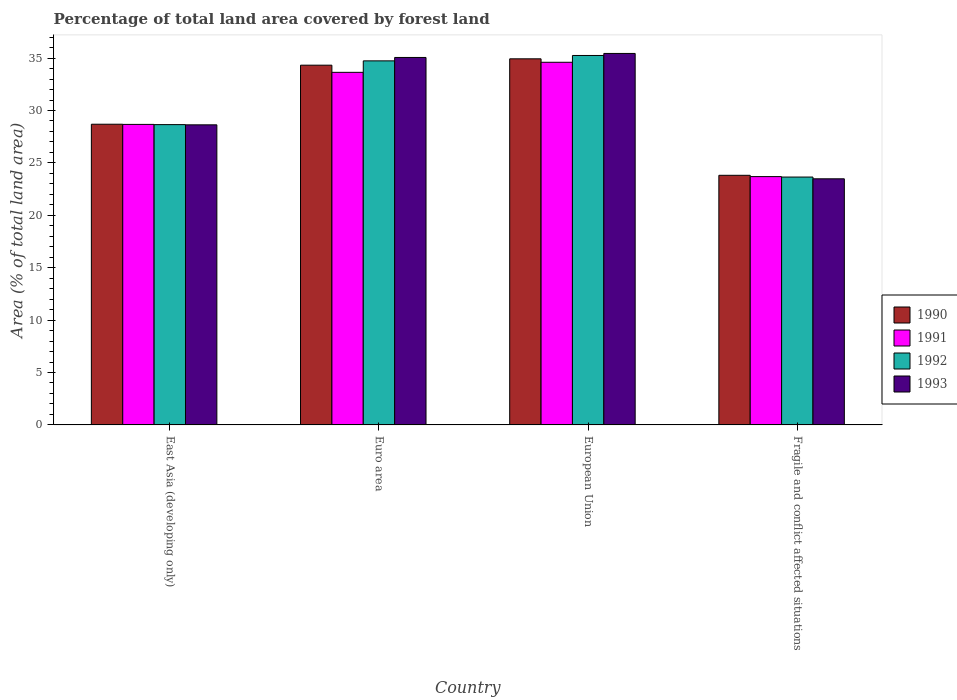How many different coloured bars are there?
Provide a short and direct response. 4. How many groups of bars are there?
Ensure brevity in your answer.  4. Are the number of bars per tick equal to the number of legend labels?
Provide a short and direct response. Yes. How many bars are there on the 4th tick from the left?
Keep it short and to the point. 4. In how many cases, is the number of bars for a given country not equal to the number of legend labels?
Ensure brevity in your answer.  0. What is the percentage of forest land in 1990 in European Union?
Ensure brevity in your answer.  34.93. Across all countries, what is the maximum percentage of forest land in 1991?
Provide a succinct answer. 34.6. Across all countries, what is the minimum percentage of forest land in 1993?
Provide a short and direct response. 23.48. In which country was the percentage of forest land in 1991 minimum?
Your response must be concise. Fragile and conflict affected situations. What is the total percentage of forest land in 1992 in the graph?
Give a very brief answer. 122.29. What is the difference between the percentage of forest land in 1990 in East Asia (developing only) and that in European Union?
Your answer should be compact. -6.24. What is the difference between the percentage of forest land in 1992 in Euro area and the percentage of forest land in 1993 in Fragile and conflict affected situations?
Your answer should be very brief. 11.25. What is the average percentage of forest land in 1993 per country?
Provide a succinct answer. 30.66. What is the difference between the percentage of forest land of/in 1993 and percentage of forest land of/in 1990 in European Union?
Your response must be concise. 0.51. In how many countries, is the percentage of forest land in 1992 greater than 2 %?
Provide a succinct answer. 4. What is the ratio of the percentage of forest land in 1993 in East Asia (developing only) to that in Fragile and conflict affected situations?
Give a very brief answer. 1.22. Is the percentage of forest land in 1992 in East Asia (developing only) less than that in Fragile and conflict affected situations?
Ensure brevity in your answer.  No. Is the difference between the percentage of forest land in 1993 in Euro area and European Union greater than the difference between the percentage of forest land in 1990 in Euro area and European Union?
Offer a very short reply. Yes. What is the difference between the highest and the second highest percentage of forest land in 1990?
Give a very brief answer. 0.61. What is the difference between the highest and the lowest percentage of forest land in 1992?
Keep it short and to the point. 11.6. Is the sum of the percentage of forest land in 1990 in East Asia (developing only) and Euro area greater than the maximum percentage of forest land in 1992 across all countries?
Your answer should be compact. Yes. Is it the case that in every country, the sum of the percentage of forest land in 1990 and percentage of forest land in 1992 is greater than the sum of percentage of forest land in 1991 and percentage of forest land in 1993?
Make the answer very short. No. What does the 2nd bar from the left in European Union represents?
Ensure brevity in your answer.  1991. Is it the case that in every country, the sum of the percentage of forest land in 1992 and percentage of forest land in 1993 is greater than the percentage of forest land in 1990?
Your answer should be very brief. Yes. Are all the bars in the graph horizontal?
Make the answer very short. No. How many countries are there in the graph?
Keep it short and to the point. 4. Are the values on the major ticks of Y-axis written in scientific E-notation?
Keep it short and to the point. No. Does the graph contain any zero values?
Provide a short and direct response. No. Where does the legend appear in the graph?
Offer a very short reply. Center right. How many legend labels are there?
Provide a short and direct response. 4. What is the title of the graph?
Your answer should be compact. Percentage of total land area covered by forest land. Does "1966" appear as one of the legend labels in the graph?
Your answer should be compact. No. What is the label or title of the X-axis?
Your answer should be very brief. Country. What is the label or title of the Y-axis?
Your response must be concise. Area (% of total land area). What is the Area (% of total land area) of 1990 in East Asia (developing only)?
Your answer should be very brief. 28.69. What is the Area (% of total land area) of 1991 in East Asia (developing only)?
Give a very brief answer. 28.68. What is the Area (% of total land area) of 1992 in East Asia (developing only)?
Your answer should be compact. 28.65. What is the Area (% of total land area) in 1993 in East Asia (developing only)?
Ensure brevity in your answer.  28.63. What is the Area (% of total land area) in 1990 in Euro area?
Make the answer very short. 34.33. What is the Area (% of total land area) of 1991 in Euro area?
Provide a short and direct response. 33.64. What is the Area (% of total land area) of 1992 in Euro area?
Provide a succinct answer. 34.74. What is the Area (% of total land area) of 1993 in Euro area?
Provide a succinct answer. 35.06. What is the Area (% of total land area) in 1990 in European Union?
Keep it short and to the point. 34.93. What is the Area (% of total land area) in 1991 in European Union?
Offer a very short reply. 34.6. What is the Area (% of total land area) in 1992 in European Union?
Ensure brevity in your answer.  35.25. What is the Area (% of total land area) of 1993 in European Union?
Keep it short and to the point. 35.45. What is the Area (% of total land area) in 1990 in Fragile and conflict affected situations?
Give a very brief answer. 23.82. What is the Area (% of total land area) of 1991 in Fragile and conflict affected situations?
Provide a short and direct response. 23.69. What is the Area (% of total land area) of 1992 in Fragile and conflict affected situations?
Offer a terse response. 23.65. What is the Area (% of total land area) in 1993 in Fragile and conflict affected situations?
Offer a terse response. 23.48. Across all countries, what is the maximum Area (% of total land area) of 1990?
Give a very brief answer. 34.93. Across all countries, what is the maximum Area (% of total land area) of 1991?
Ensure brevity in your answer.  34.6. Across all countries, what is the maximum Area (% of total land area) in 1992?
Give a very brief answer. 35.25. Across all countries, what is the maximum Area (% of total land area) in 1993?
Ensure brevity in your answer.  35.45. Across all countries, what is the minimum Area (% of total land area) of 1990?
Provide a succinct answer. 23.82. Across all countries, what is the minimum Area (% of total land area) in 1991?
Make the answer very short. 23.69. Across all countries, what is the minimum Area (% of total land area) in 1992?
Provide a short and direct response. 23.65. Across all countries, what is the minimum Area (% of total land area) in 1993?
Keep it short and to the point. 23.48. What is the total Area (% of total land area) of 1990 in the graph?
Make the answer very short. 121.77. What is the total Area (% of total land area) in 1991 in the graph?
Provide a short and direct response. 120.62. What is the total Area (% of total land area) in 1992 in the graph?
Offer a very short reply. 122.29. What is the total Area (% of total land area) of 1993 in the graph?
Ensure brevity in your answer.  122.63. What is the difference between the Area (% of total land area) of 1990 in East Asia (developing only) and that in Euro area?
Keep it short and to the point. -5.63. What is the difference between the Area (% of total land area) of 1991 in East Asia (developing only) and that in Euro area?
Provide a short and direct response. -4.97. What is the difference between the Area (% of total land area) in 1992 in East Asia (developing only) and that in Euro area?
Make the answer very short. -6.08. What is the difference between the Area (% of total land area) in 1993 in East Asia (developing only) and that in Euro area?
Keep it short and to the point. -6.43. What is the difference between the Area (% of total land area) in 1990 in East Asia (developing only) and that in European Union?
Make the answer very short. -6.24. What is the difference between the Area (% of total land area) in 1991 in East Asia (developing only) and that in European Union?
Make the answer very short. -5.93. What is the difference between the Area (% of total land area) of 1992 in East Asia (developing only) and that in European Union?
Your answer should be very brief. -6.6. What is the difference between the Area (% of total land area) in 1993 in East Asia (developing only) and that in European Union?
Provide a short and direct response. -6.81. What is the difference between the Area (% of total land area) of 1990 in East Asia (developing only) and that in Fragile and conflict affected situations?
Ensure brevity in your answer.  4.87. What is the difference between the Area (% of total land area) of 1991 in East Asia (developing only) and that in Fragile and conflict affected situations?
Provide a short and direct response. 4.98. What is the difference between the Area (% of total land area) of 1992 in East Asia (developing only) and that in Fragile and conflict affected situations?
Ensure brevity in your answer.  5. What is the difference between the Area (% of total land area) of 1993 in East Asia (developing only) and that in Fragile and conflict affected situations?
Your answer should be compact. 5.15. What is the difference between the Area (% of total land area) of 1990 in Euro area and that in European Union?
Your response must be concise. -0.61. What is the difference between the Area (% of total land area) in 1991 in Euro area and that in European Union?
Keep it short and to the point. -0.96. What is the difference between the Area (% of total land area) of 1992 in Euro area and that in European Union?
Provide a succinct answer. -0.51. What is the difference between the Area (% of total land area) of 1993 in Euro area and that in European Union?
Provide a succinct answer. -0.38. What is the difference between the Area (% of total land area) in 1990 in Euro area and that in Fragile and conflict affected situations?
Offer a terse response. 10.51. What is the difference between the Area (% of total land area) of 1991 in Euro area and that in Fragile and conflict affected situations?
Offer a very short reply. 9.95. What is the difference between the Area (% of total land area) in 1992 in Euro area and that in Fragile and conflict affected situations?
Offer a very short reply. 11.09. What is the difference between the Area (% of total land area) of 1993 in Euro area and that in Fragile and conflict affected situations?
Make the answer very short. 11.58. What is the difference between the Area (% of total land area) of 1990 in European Union and that in Fragile and conflict affected situations?
Your answer should be compact. 11.12. What is the difference between the Area (% of total land area) of 1991 in European Union and that in Fragile and conflict affected situations?
Your answer should be compact. 10.91. What is the difference between the Area (% of total land area) of 1992 in European Union and that in Fragile and conflict affected situations?
Your response must be concise. 11.6. What is the difference between the Area (% of total land area) in 1993 in European Union and that in Fragile and conflict affected situations?
Offer a terse response. 11.96. What is the difference between the Area (% of total land area) of 1990 in East Asia (developing only) and the Area (% of total land area) of 1991 in Euro area?
Keep it short and to the point. -4.95. What is the difference between the Area (% of total land area) in 1990 in East Asia (developing only) and the Area (% of total land area) in 1992 in Euro area?
Provide a succinct answer. -6.05. What is the difference between the Area (% of total land area) of 1990 in East Asia (developing only) and the Area (% of total land area) of 1993 in Euro area?
Offer a terse response. -6.37. What is the difference between the Area (% of total land area) in 1991 in East Asia (developing only) and the Area (% of total land area) in 1992 in Euro area?
Your answer should be very brief. -6.06. What is the difference between the Area (% of total land area) of 1991 in East Asia (developing only) and the Area (% of total land area) of 1993 in Euro area?
Provide a short and direct response. -6.39. What is the difference between the Area (% of total land area) of 1992 in East Asia (developing only) and the Area (% of total land area) of 1993 in Euro area?
Offer a terse response. -6.41. What is the difference between the Area (% of total land area) of 1990 in East Asia (developing only) and the Area (% of total land area) of 1991 in European Union?
Your answer should be very brief. -5.91. What is the difference between the Area (% of total land area) in 1990 in East Asia (developing only) and the Area (% of total land area) in 1992 in European Union?
Keep it short and to the point. -6.56. What is the difference between the Area (% of total land area) of 1990 in East Asia (developing only) and the Area (% of total land area) of 1993 in European Union?
Give a very brief answer. -6.75. What is the difference between the Area (% of total land area) of 1991 in East Asia (developing only) and the Area (% of total land area) of 1992 in European Union?
Ensure brevity in your answer.  -6.58. What is the difference between the Area (% of total land area) of 1991 in East Asia (developing only) and the Area (% of total land area) of 1993 in European Union?
Provide a succinct answer. -6.77. What is the difference between the Area (% of total land area) of 1992 in East Asia (developing only) and the Area (% of total land area) of 1993 in European Union?
Ensure brevity in your answer.  -6.79. What is the difference between the Area (% of total land area) of 1990 in East Asia (developing only) and the Area (% of total land area) of 1991 in Fragile and conflict affected situations?
Keep it short and to the point. 5. What is the difference between the Area (% of total land area) in 1990 in East Asia (developing only) and the Area (% of total land area) in 1992 in Fragile and conflict affected situations?
Your answer should be very brief. 5.04. What is the difference between the Area (% of total land area) in 1990 in East Asia (developing only) and the Area (% of total land area) in 1993 in Fragile and conflict affected situations?
Your response must be concise. 5.21. What is the difference between the Area (% of total land area) of 1991 in East Asia (developing only) and the Area (% of total land area) of 1992 in Fragile and conflict affected situations?
Give a very brief answer. 5.02. What is the difference between the Area (% of total land area) of 1991 in East Asia (developing only) and the Area (% of total land area) of 1993 in Fragile and conflict affected situations?
Ensure brevity in your answer.  5.19. What is the difference between the Area (% of total land area) in 1992 in East Asia (developing only) and the Area (% of total land area) in 1993 in Fragile and conflict affected situations?
Provide a short and direct response. 5.17. What is the difference between the Area (% of total land area) in 1990 in Euro area and the Area (% of total land area) in 1991 in European Union?
Your response must be concise. -0.28. What is the difference between the Area (% of total land area) in 1990 in Euro area and the Area (% of total land area) in 1992 in European Union?
Offer a terse response. -0.93. What is the difference between the Area (% of total land area) of 1990 in Euro area and the Area (% of total land area) of 1993 in European Union?
Give a very brief answer. -1.12. What is the difference between the Area (% of total land area) of 1991 in Euro area and the Area (% of total land area) of 1992 in European Union?
Provide a short and direct response. -1.61. What is the difference between the Area (% of total land area) in 1991 in Euro area and the Area (% of total land area) in 1993 in European Union?
Your answer should be very brief. -1.8. What is the difference between the Area (% of total land area) of 1992 in Euro area and the Area (% of total land area) of 1993 in European Union?
Your answer should be very brief. -0.71. What is the difference between the Area (% of total land area) in 1990 in Euro area and the Area (% of total land area) in 1991 in Fragile and conflict affected situations?
Your answer should be compact. 10.63. What is the difference between the Area (% of total land area) in 1990 in Euro area and the Area (% of total land area) in 1992 in Fragile and conflict affected situations?
Your answer should be compact. 10.68. What is the difference between the Area (% of total land area) in 1990 in Euro area and the Area (% of total land area) in 1993 in Fragile and conflict affected situations?
Make the answer very short. 10.84. What is the difference between the Area (% of total land area) in 1991 in Euro area and the Area (% of total land area) in 1992 in Fragile and conflict affected situations?
Offer a terse response. 9.99. What is the difference between the Area (% of total land area) in 1991 in Euro area and the Area (% of total land area) in 1993 in Fragile and conflict affected situations?
Offer a terse response. 10.16. What is the difference between the Area (% of total land area) of 1992 in Euro area and the Area (% of total land area) of 1993 in Fragile and conflict affected situations?
Provide a short and direct response. 11.25. What is the difference between the Area (% of total land area) in 1990 in European Union and the Area (% of total land area) in 1991 in Fragile and conflict affected situations?
Offer a terse response. 11.24. What is the difference between the Area (% of total land area) in 1990 in European Union and the Area (% of total land area) in 1992 in Fragile and conflict affected situations?
Your answer should be very brief. 11.28. What is the difference between the Area (% of total land area) in 1990 in European Union and the Area (% of total land area) in 1993 in Fragile and conflict affected situations?
Ensure brevity in your answer.  11.45. What is the difference between the Area (% of total land area) of 1991 in European Union and the Area (% of total land area) of 1992 in Fragile and conflict affected situations?
Keep it short and to the point. 10.95. What is the difference between the Area (% of total land area) in 1991 in European Union and the Area (% of total land area) in 1993 in Fragile and conflict affected situations?
Your response must be concise. 11.12. What is the difference between the Area (% of total land area) of 1992 in European Union and the Area (% of total land area) of 1993 in Fragile and conflict affected situations?
Make the answer very short. 11.77. What is the average Area (% of total land area) of 1990 per country?
Give a very brief answer. 30.44. What is the average Area (% of total land area) in 1991 per country?
Ensure brevity in your answer.  30.15. What is the average Area (% of total land area) in 1992 per country?
Your answer should be very brief. 30.57. What is the average Area (% of total land area) in 1993 per country?
Ensure brevity in your answer.  30.66. What is the difference between the Area (% of total land area) of 1990 and Area (% of total land area) of 1991 in East Asia (developing only)?
Make the answer very short. 0.02. What is the difference between the Area (% of total land area) of 1990 and Area (% of total land area) of 1992 in East Asia (developing only)?
Give a very brief answer. 0.04. What is the difference between the Area (% of total land area) of 1990 and Area (% of total land area) of 1993 in East Asia (developing only)?
Give a very brief answer. 0.06. What is the difference between the Area (% of total land area) of 1991 and Area (% of total land area) of 1992 in East Asia (developing only)?
Provide a short and direct response. 0.02. What is the difference between the Area (% of total land area) in 1991 and Area (% of total land area) in 1993 in East Asia (developing only)?
Your answer should be very brief. 0.04. What is the difference between the Area (% of total land area) in 1992 and Area (% of total land area) in 1993 in East Asia (developing only)?
Keep it short and to the point. 0.02. What is the difference between the Area (% of total land area) in 1990 and Area (% of total land area) in 1991 in Euro area?
Ensure brevity in your answer.  0.68. What is the difference between the Area (% of total land area) of 1990 and Area (% of total land area) of 1992 in Euro area?
Offer a terse response. -0.41. What is the difference between the Area (% of total land area) in 1990 and Area (% of total land area) in 1993 in Euro area?
Your answer should be very brief. -0.74. What is the difference between the Area (% of total land area) in 1991 and Area (% of total land area) in 1992 in Euro area?
Keep it short and to the point. -1.09. What is the difference between the Area (% of total land area) of 1991 and Area (% of total land area) of 1993 in Euro area?
Provide a short and direct response. -1.42. What is the difference between the Area (% of total land area) in 1992 and Area (% of total land area) in 1993 in Euro area?
Your response must be concise. -0.33. What is the difference between the Area (% of total land area) in 1990 and Area (% of total land area) in 1991 in European Union?
Provide a short and direct response. 0.33. What is the difference between the Area (% of total land area) of 1990 and Area (% of total land area) of 1992 in European Union?
Offer a terse response. -0.32. What is the difference between the Area (% of total land area) of 1990 and Area (% of total land area) of 1993 in European Union?
Provide a short and direct response. -0.51. What is the difference between the Area (% of total land area) in 1991 and Area (% of total land area) in 1992 in European Union?
Provide a succinct answer. -0.65. What is the difference between the Area (% of total land area) of 1991 and Area (% of total land area) of 1993 in European Union?
Ensure brevity in your answer.  -0.84. What is the difference between the Area (% of total land area) of 1992 and Area (% of total land area) of 1993 in European Union?
Ensure brevity in your answer.  -0.19. What is the difference between the Area (% of total land area) of 1990 and Area (% of total land area) of 1991 in Fragile and conflict affected situations?
Ensure brevity in your answer.  0.12. What is the difference between the Area (% of total land area) in 1990 and Area (% of total land area) in 1992 in Fragile and conflict affected situations?
Make the answer very short. 0.17. What is the difference between the Area (% of total land area) in 1991 and Area (% of total land area) in 1992 in Fragile and conflict affected situations?
Your answer should be compact. 0.04. What is the difference between the Area (% of total land area) of 1991 and Area (% of total land area) of 1993 in Fragile and conflict affected situations?
Provide a succinct answer. 0.21. What is the difference between the Area (% of total land area) in 1992 and Area (% of total land area) in 1993 in Fragile and conflict affected situations?
Your response must be concise. 0.17. What is the ratio of the Area (% of total land area) of 1990 in East Asia (developing only) to that in Euro area?
Your response must be concise. 0.84. What is the ratio of the Area (% of total land area) of 1991 in East Asia (developing only) to that in Euro area?
Your response must be concise. 0.85. What is the ratio of the Area (% of total land area) of 1992 in East Asia (developing only) to that in Euro area?
Your answer should be compact. 0.82. What is the ratio of the Area (% of total land area) of 1993 in East Asia (developing only) to that in Euro area?
Offer a very short reply. 0.82. What is the ratio of the Area (% of total land area) in 1990 in East Asia (developing only) to that in European Union?
Your answer should be very brief. 0.82. What is the ratio of the Area (% of total land area) of 1991 in East Asia (developing only) to that in European Union?
Ensure brevity in your answer.  0.83. What is the ratio of the Area (% of total land area) in 1992 in East Asia (developing only) to that in European Union?
Provide a succinct answer. 0.81. What is the ratio of the Area (% of total land area) of 1993 in East Asia (developing only) to that in European Union?
Ensure brevity in your answer.  0.81. What is the ratio of the Area (% of total land area) of 1990 in East Asia (developing only) to that in Fragile and conflict affected situations?
Your answer should be very brief. 1.2. What is the ratio of the Area (% of total land area) in 1991 in East Asia (developing only) to that in Fragile and conflict affected situations?
Ensure brevity in your answer.  1.21. What is the ratio of the Area (% of total land area) in 1992 in East Asia (developing only) to that in Fragile and conflict affected situations?
Make the answer very short. 1.21. What is the ratio of the Area (% of total land area) of 1993 in East Asia (developing only) to that in Fragile and conflict affected situations?
Provide a succinct answer. 1.22. What is the ratio of the Area (% of total land area) in 1990 in Euro area to that in European Union?
Your response must be concise. 0.98. What is the ratio of the Area (% of total land area) in 1991 in Euro area to that in European Union?
Keep it short and to the point. 0.97. What is the ratio of the Area (% of total land area) of 1992 in Euro area to that in European Union?
Provide a short and direct response. 0.99. What is the ratio of the Area (% of total land area) in 1990 in Euro area to that in Fragile and conflict affected situations?
Make the answer very short. 1.44. What is the ratio of the Area (% of total land area) in 1991 in Euro area to that in Fragile and conflict affected situations?
Provide a succinct answer. 1.42. What is the ratio of the Area (% of total land area) in 1992 in Euro area to that in Fragile and conflict affected situations?
Make the answer very short. 1.47. What is the ratio of the Area (% of total land area) in 1993 in Euro area to that in Fragile and conflict affected situations?
Give a very brief answer. 1.49. What is the ratio of the Area (% of total land area) of 1990 in European Union to that in Fragile and conflict affected situations?
Your answer should be compact. 1.47. What is the ratio of the Area (% of total land area) of 1991 in European Union to that in Fragile and conflict affected situations?
Your answer should be compact. 1.46. What is the ratio of the Area (% of total land area) in 1992 in European Union to that in Fragile and conflict affected situations?
Offer a terse response. 1.49. What is the ratio of the Area (% of total land area) of 1993 in European Union to that in Fragile and conflict affected situations?
Offer a terse response. 1.51. What is the difference between the highest and the second highest Area (% of total land area) in 1990?
Ensure brevity in your answer.  0.61. What is the difference between the highest and the second highest Area (% of total land area) of 1991?
Provide a short and direct response. 0.96. What is the difference between the highest and the second highest Area (% of total land area) of 1992?
Provide a succinct answer. 0.51. What is the difference between the highest and the second highest Area (% of total land area) in 1993?
Your response must be concise. 0.38. What is the difference between the highest and the lowest Area (% of total land area) of 1990?
Your answer should be very brief. 11.12. What is the difference between the highest and the lowest Area (% of total land area) of 1991?
Keep it short and to the point. 10.91. What is the difference between the highest and the lowest Area (% of total land area) of 1992?
Ensure brevity in your answer.  11.6. What is the difference between the highest and the lowest Area (% of total land area) of 1993?
Offer a very short reply. 11.96. 